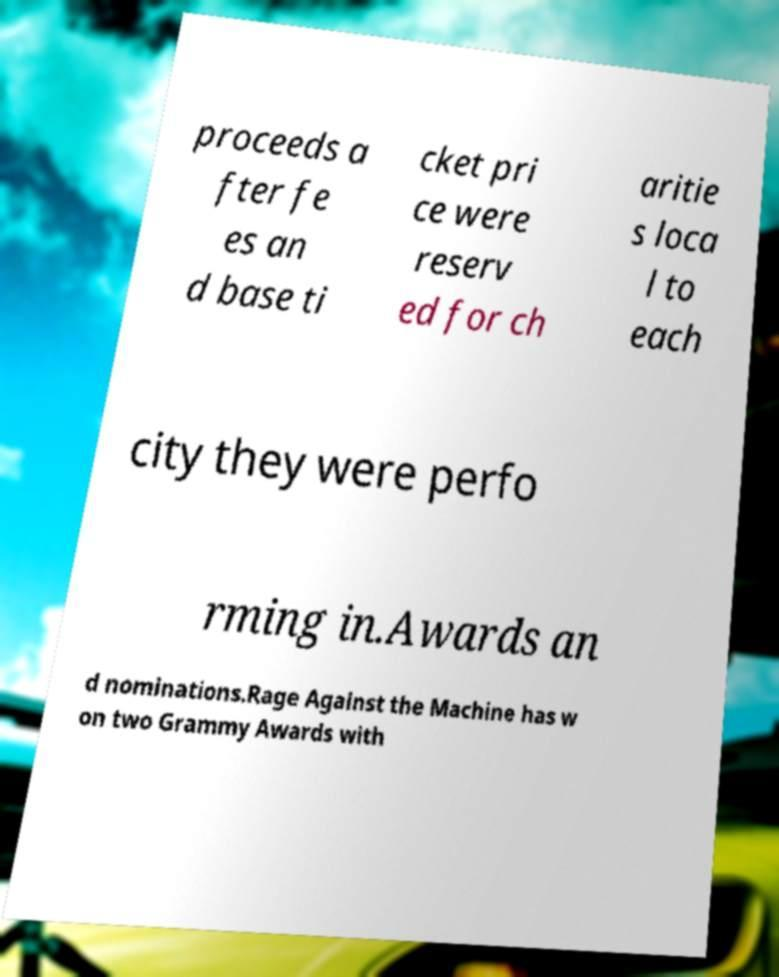What messages or text are displayed in this image? I need them in a readable, typed format. proceeds a fter fe es an d base ti cket pri ce were reserv ed for ch aritie s loca l to each city they were perfo rming in.Awards an d nominations.Rage Against the Machine has w on two Grammy Awards with 